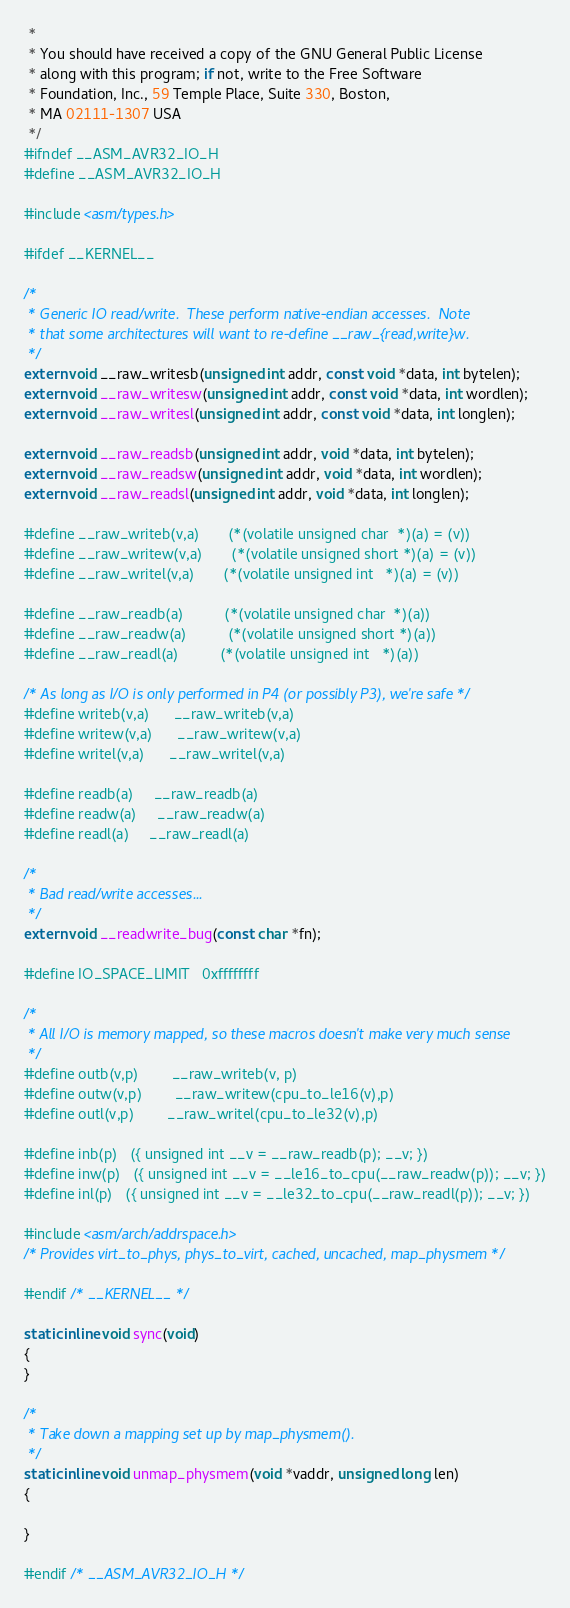<code> <loc_0><loc_0><loc_500><loc_500><_C_> *
 * You should have received a copy of the GNU General Public License
 * along with this program; if not, write to the Free Software
 * Foundation, Inc., 59 Temple Place, Suite 330, Boston,
 * MA 02111-1307 USA
 */
#ifndef __ASM_AVR32_IO_H
#define __ASM_AVR32_IO_H

#include <asm/types.h>

#ifdef __KERNEL__

/*
 * Generic IO read/write.  These perform native-endian accesses.  Note
 * that some architectures will want to re-define __raw_{read,write}w.
 */
extern void __raw_writesb(unsigned int addr, const void *data, int bytelen);
extern void __raw_writesw(unsigned int addr, const void *data, int wordlen);
extern void __raw_writesl(unsigned int addr, const void *data, int longlen);

extern void __raw_readsb(unsigned int addr, void *data, int bytelen);
extern void __raw_readsw(unsigned int addr, void *data, int wordlen);
extern void __raw_readsl(unsigned int addr, void *data, int longlen);

#define __raw_writeb(v,a)       (*(volatile unsigned char  *)(a) = (v))
#define __raw_writew(v,a)       (*(volatile unsigned short *)(a) = (v))
#define __raw_writel(v,a)       (*(volatile unsigned int   *)(a) = (v))

#define __raw_readb(a)          (*(volatile unsigned char  *)(a))
#define __raw_readw(a)          (*(volatile unsigned short *)(a))
#define __raw_readl(a)          (*(volatile unsigned int   *)(a))

/* As long as I/O is only performed in P4 (or possibly P3), we're safe */
#define writeb(v,a)		__raw_writeb(v,a)
#define writew(v,a)		__raw_writew(v,a)
#define writel(v,a)		__raw_writel(v,a)

#define readb(a)		__raw_readb(a)
#define readw(a)		__raw_readw(a)
#define readl(a)		__raw_readl(a)

/*
 * Bad read/write accesses...
 */
extern void __readwrite_bug(const char *fn);

#define IO_SPACE_LIMIT	0xffffffff

/*
 * All I/O is memory mapped, so these macros doesn't make very much sense
 */
#define outb(v,p)		__raw_writeb(v, p)
#define outw(v,p)		__raw_writew(cpu_to_le16(v),p)
#define outl(v,p)		__raw_writel(cpu_to_le32(v),p)

#define inb(p)	({ unsigned int __v = __raw_readb(p); __v; })
#define inw(p)	({ unsigned int __v = __le16_to_cpu(__raw_readw(p)); __v; })
#define inl(p)	({ unsigned int __v = __le32_to_cpu(__raw_readl(p)); __v; })

#include <asm/arch/addrspace.h>
/* Provides virt_to_phys, phys_to_virt, cached, uncached, map_physmem */

#endif /* __KERNEL__ */

static inline void sync(void)
{
}

/*
 * Take down a mapping set up by map_physmem().
 */
static inline void unmap_physmem(void *vaddr, unsigned long len)
{

}

#endif /* __ASM_AVR32_IO_H */
</code> 